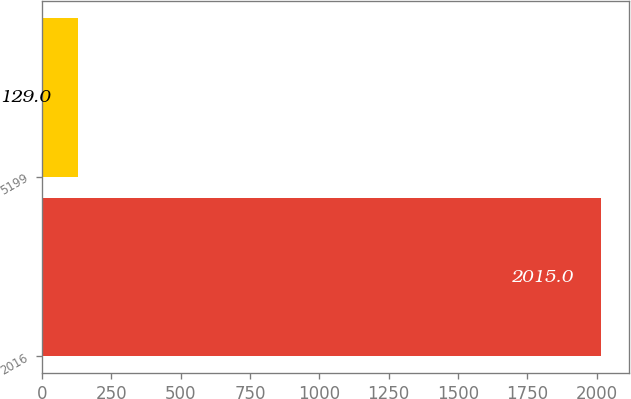Convert chart to OTSL. <chart><loc_0><loc_0><loc_500><loc_500><bar_chart><fcel>2016<fcel>5199<nl><fcel>2015<fcel>129<nl></chart> 